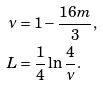Convert formula to latex. <formula><loc_0><loc_0><loc_500><loc_500>\nu & = 1 - \frac { 1 6 m } { 3 } , \\ \quad L & = \frac { 1 } { 4 } \ln \frac { 4 } { \nu } .</formula> 